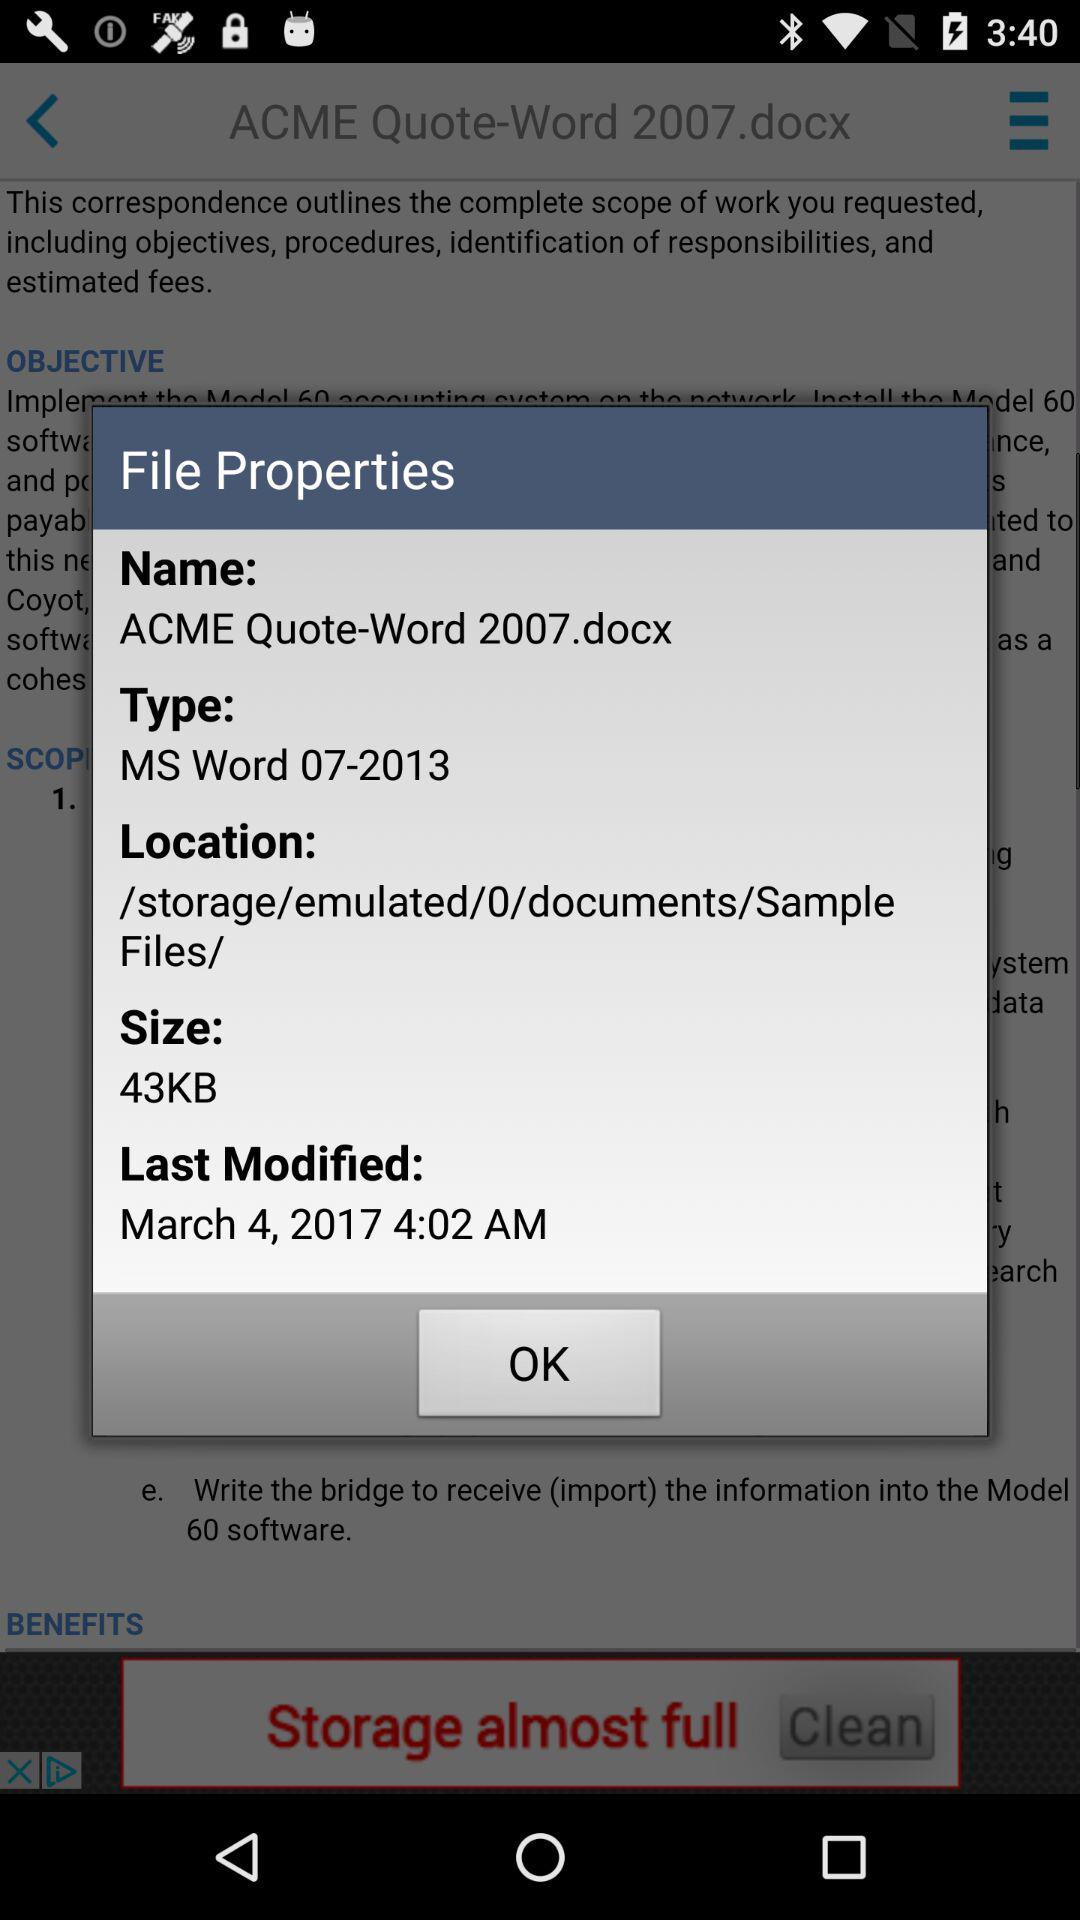What is the name of the file? The name of the file is "ACME Quote-Word 2007.docx". 